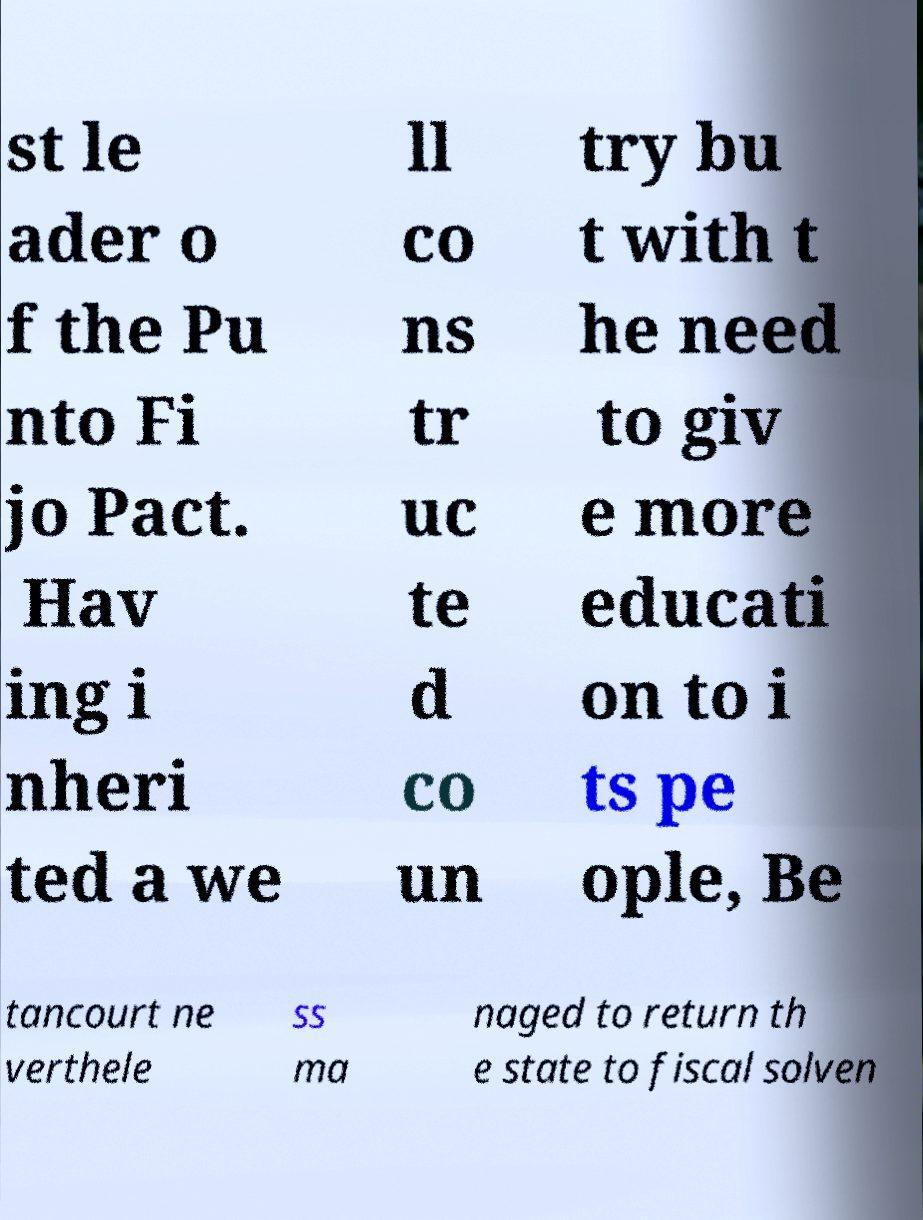Could you assist in decoding the text presented in this image and type it out clearly? st le ader o f the Pu nto Fi jo Pact. Hav ing i nheri ted a we ll co ns tr uc te d co un try bu t with t he need to giv e more educati on to i ts pe ople, Be tancourt ne verthele ss ma naged to return th e state to fiscal solven 